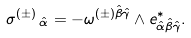Convert formula to latex. <formula><loc_0><loc_0><loc_500><loc_500>\sigma ^ { ( \pm ) } \, _ { \hat { \alpha } } = - \omega ^ { ( \pm ) \hat { \beta } \hat { \gamma } } \wedge e ^ { \ast } _ { \hat { \alpha } \hat { \beta } \hat { \gamma } } .</formula> 